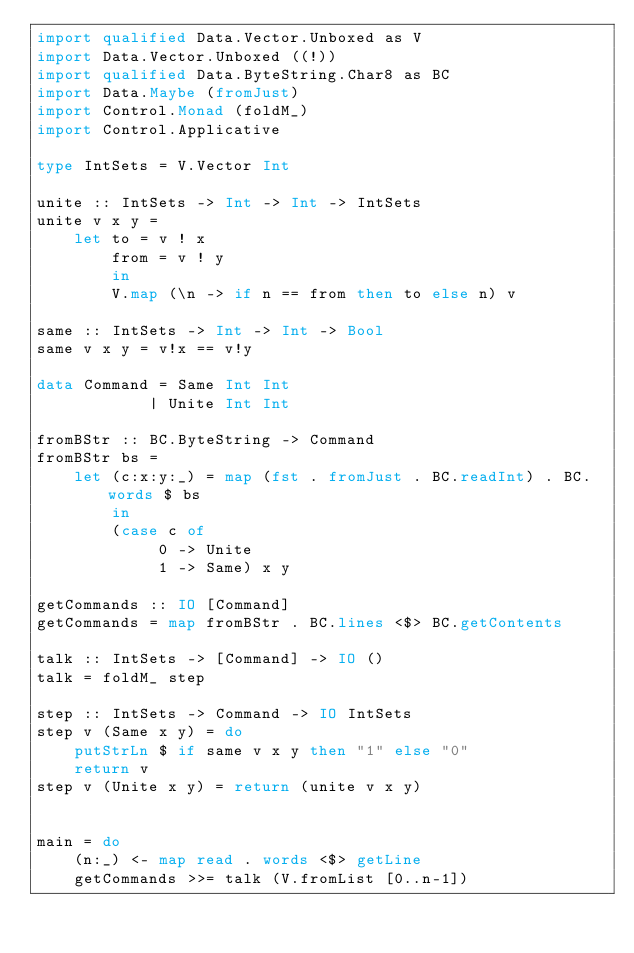Convert code to text. <code><loc_0><loc_0><loc_500><loc_500><_Haskell_>import qualified Data.Vector.Unboxed as V
import Data.Vector.Unboxed ((!))
import qualified Data.ByteString.Char8 as BC
import Data.Maybe (fromJust)
import Control.Monad (foldM_)
import Control.Applicative

type IntSets = V.Vector Int

unite :: IntSets -> Int -> Int -> IntSets
unite v x y =
    let to = v ! x
        from = v ! y
        in
        V.map (\n -> if n == from then to else n) v

same :: IntSets -> Int -> Int -> Bool
same v x y = v!x == v!y

data Command = Same Int Int
            | Unite Int Int

fromBStr :: BC.ByteString -> Command
fromBStr bs =
    let (c:x:y:_) = map (fst . fromJust . BC.readInt) . BC.words $ bs
        in
        (case c of
             0 -> Unite
             1 -> Same) x y

getCommands :: IO [Command]
getCommands = map fromBStr . BC.lines <$> BC.getContents

talk :: IntSets -> [Command] -> IO ()
talk = foldM_ step

step :: IntSets -> Command -> IO IntSets
step v (Same x y) = do
    putStrLn $ if same v x y then "1" else "0"
    return v
step v (Unite x y) = return (unite v x y)


main = do
    (n:_) <- map read . words <$> getLine
    getCommands >>= talk (V.fromList [0..n-1])</code> 